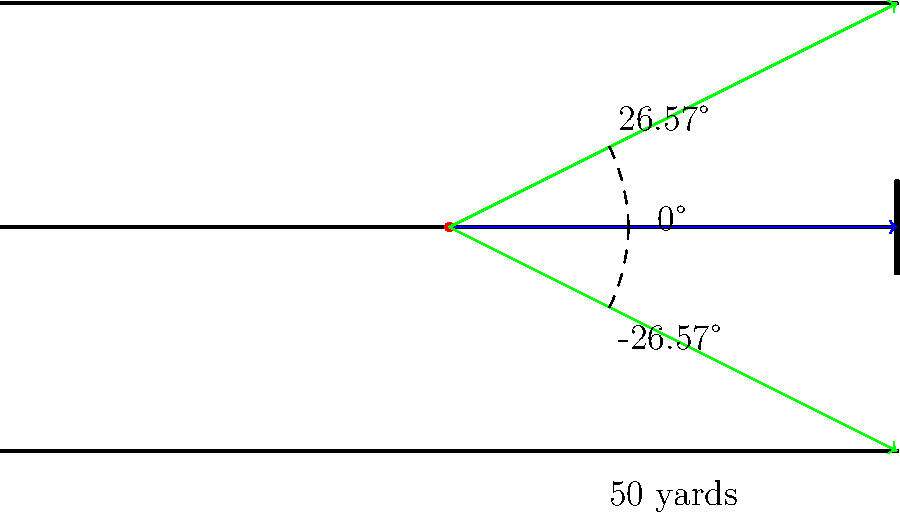As a former football player, you know the importance of field goal accuracy. Using the protractor overlay on this football field diagram, what is the optimal angle range for kicking a field goal from the 50-yard line, assuming the goalposts are 18.5 feet (6 yards) wide? To solve this problem, we'll follow these steps:

1) First, we need to understand the geometry of the situation. The kicker is at the center of the field, 50 yards away from the goal posts.

2) The goal posts are 18.5 feet wide, which is equivalent to 6 yards.

3) We can create a right triangle where:
   - The base is 50 yards (distance to goal posts)
   - Half of the goal post width is 3 yards (6 yards / 2)

4) To find the angle, we use the tangent function:

   $$\tan(\theta) = \frac{\text{opposite}}{\text{adjacent}} = \frac{3}{50}$$

5) To solve for $\theta$, we use the inverse tangent (arctangent):

   $$\theta = \arctan(\frac{3}{50}) \approx 0.0599 \text{ radians}$$

6) Convert radians to degrees:

   $$0.0599 \text{ radians} \times \frac{180°}{\pi} \approx 3.43°$$

7) This angle represents half of the total angle range. The full range would be double this:

   $$3.43° \times 2 \approx 6.86°$$

8) Therefore, the optimal angle range is from -3.43° to +3.43°, or ±3.43°.

However, the diagram shows a much wider angle of ±26.57°. This larger angle likely represents the maximum possible angle for a successful field goal, taking into account factors like wind, slight inaccuracies in the kick, and the height of the ball as it passes through the uprights.
Answer: ±3.43° 